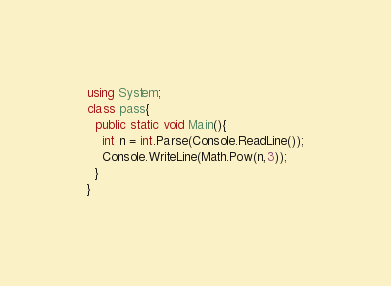Convert code to text. <code><loc_0><loc_0><loc_500><loc_500><_C#_>using System;
class pass{
  public static void Main(){
    int n = int.Parse(Console.ReadLine());
    Console.WriteLine(Math.Pow(n,3));
  }
}
</code> 